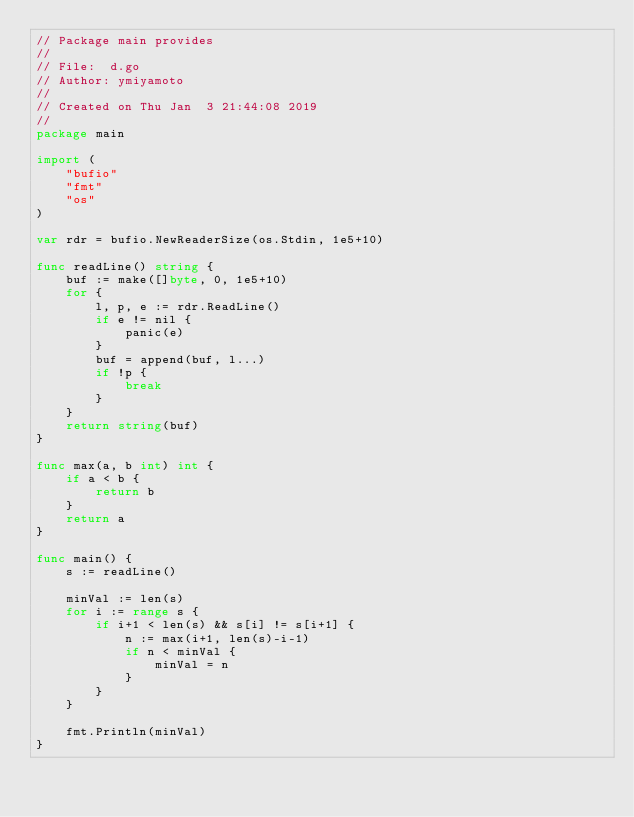Convert code to text. <code><loc_0><loc_0><loc_500><loc_500><_Go_>// Package main provides
//
// File:  d.go
// Author: ymiyamoto
//
// Created on Thu Jan  3 21:44:08 2019
//
package main

import (
	"bufio"
	"fmt"
	"os"
)

var rdr = bufio.NewReaderSize(os.Stdin, 1e5+10)

func readLine() string {
	buf := make([]byte, 0, 1e5+10)
	for {
		l, p, e := rdr.ReadLine()
		if e != nil {
			panic(e)
		}
		buf = append(buf, l...)
		if !p {
			break
		}
	}
	return string(buf)
}

func max(a, b int) int {
	if a < b {
		return b
	}
	return a
}

func main() {
	s := readLine()

	minVal := len(s)
	for i := range s {
		if i+1 < len(s) && s[i] != s[i+1] {
			n := max(i+1, len(s)-i-1)
			if n < minVal {
				minVal = n
			}
		}
	}

	fmt.Println(minVal)
}
</code> 